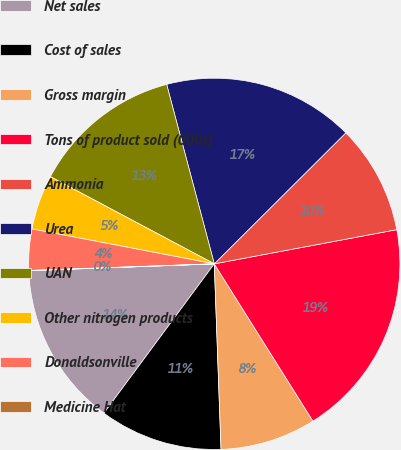<chart> <loc_0><loc_0><loc_500><loc_500><pie_chart><fcel>Net sales<fcel>Cost of sales<fcel>Gross margin<fcel>Tons of product sold (000s)<fcel>Ammonia<fcel>Urea<fcel>UAN<fcel>Other nitrogen products<fcel>Donaldsonville<fcel>Medicine Hat<nl><fcel>14.28%<fcel>10.71%<fcel>8.34%<fcel>19.03%<fcel>9.52%<fcel>16.66%<fcel>13.09%<fcel>4.77%<fcel>3.58%<fcel>0.02%<nl></chart> 